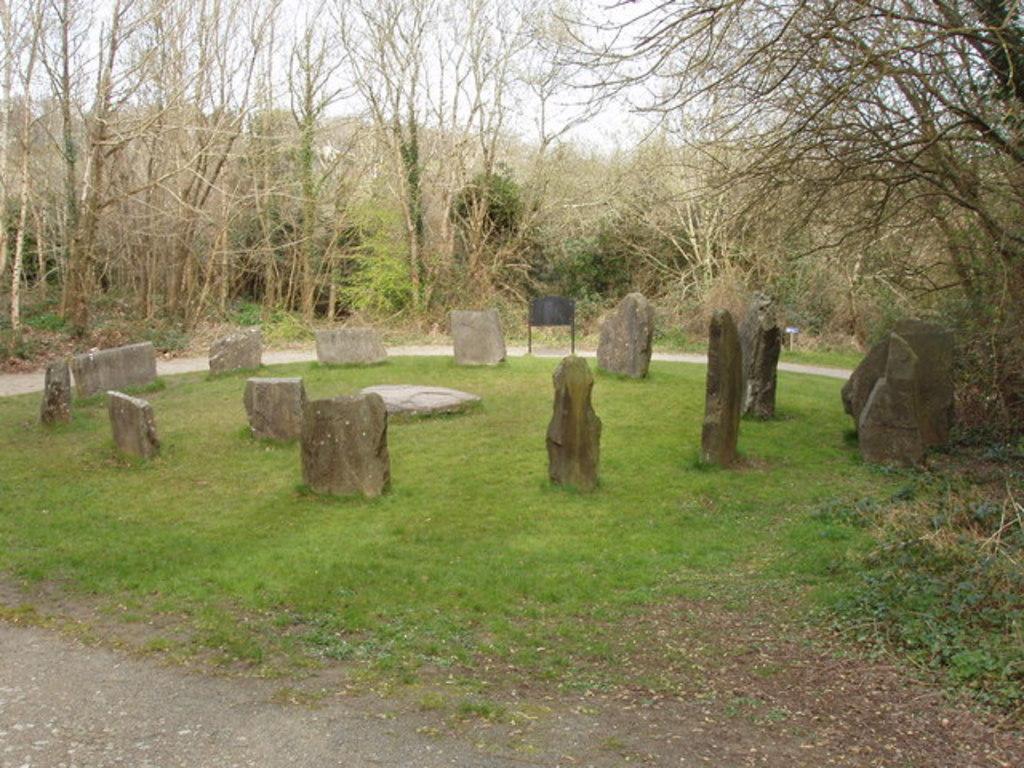Could you give a brief overview of what you see in this image? In this image, we can see some trees. There are some stones in the middle of the image. 